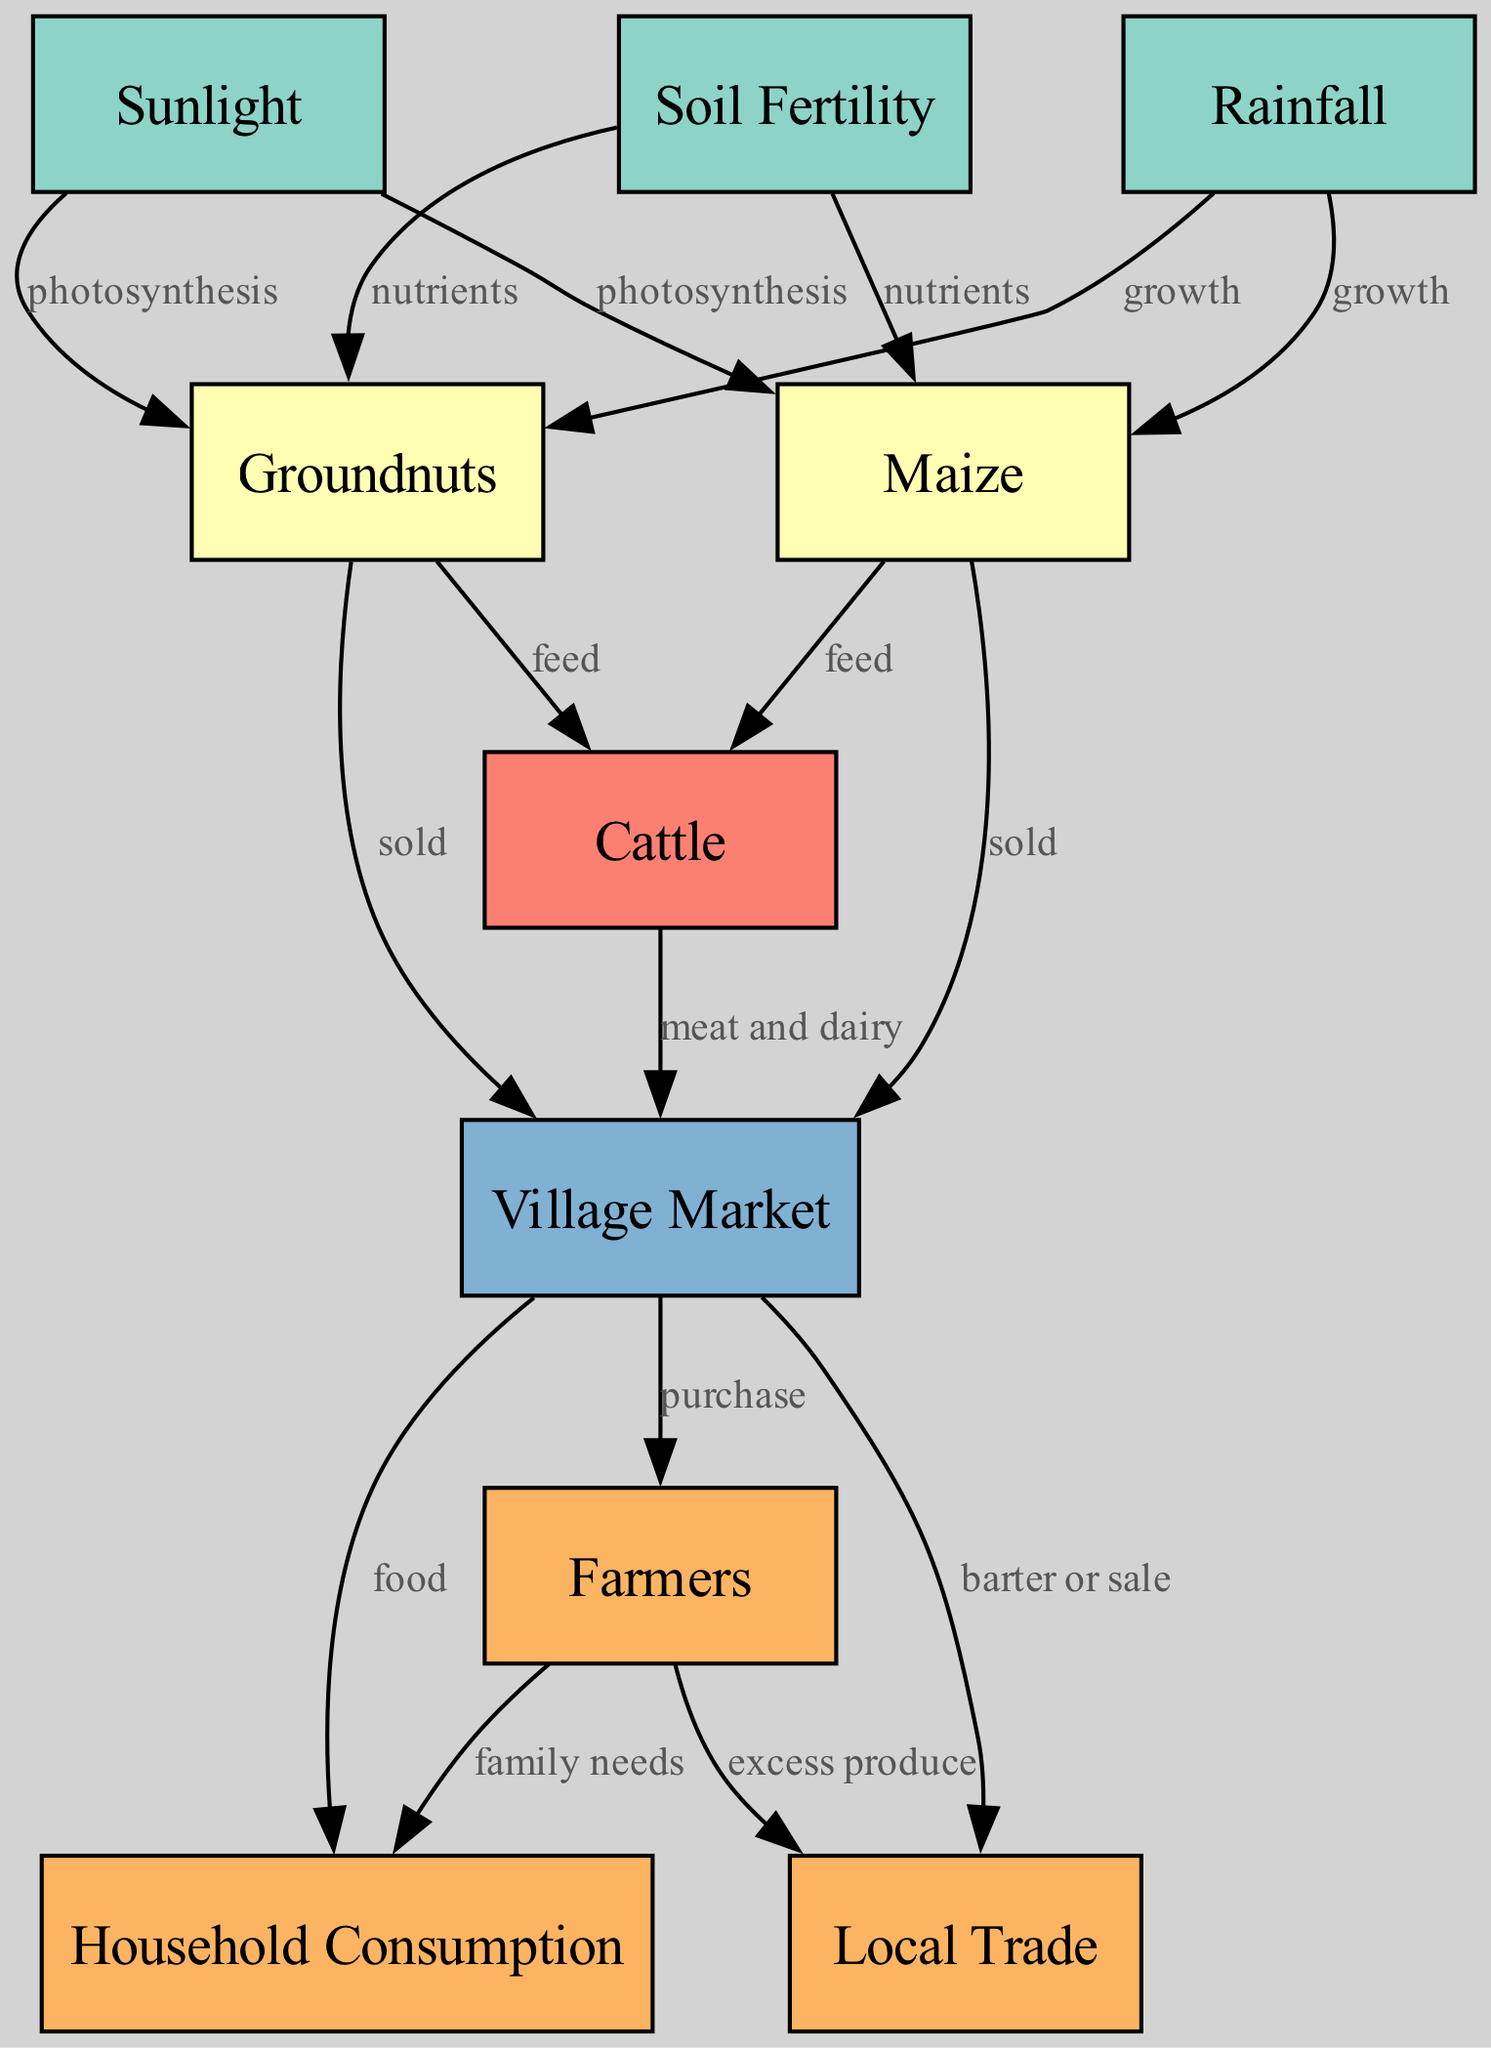What are the three elements in the environmental category? The environmental category consists of nodes that represent fundamental components affecting the food chain. These are Sunlight, Rainfall, and Soil Fertility.
Answer: Sunlight, Rainfall, Soil Fertility How many crop nodes are present in the diagram? The crop nodes are identified as Maize and Groundnuts. Counting these gives a total of two crop nodes in the diagram.
Answer: 2 What do farmers primarily purchase from the village market? The village market connects to several nodes, but the primary products associated with it include food and other goods that fulfill family needs. Hence, the primary focus would be on food.
Answer: Food What type of animal is primarily fed by maize? Maize serves as feed not only for cattle but also for other livestock in the agricultural context, indicating that the primary animal fed is cattle.
Answer: Cattle How does rainfall directly influence crops in the diagram? Rainfall has a direct link to both maize and groundnuts as it facilitates their growth. This relationship shows how rainfall is essential for crop health.
Answer: Growth Which node illustrates the final step of the local food chain? The local food chain culminates at the Household Consumption node, demonstrating where food produced is ultimately consumed.
Answer: Household Consumption What relationships connect cattle to the village market? Cattle produce meat and dairy products, which are sold at the village market. Thus, the relationships include the transformation of cattle into marketable products.
Answer: Meat and dairy What do farmers do with excess produce according to the diagram? Any surplus yield from farming is directed towards local trade, indicating that farmers engage in barter or sale to utilize their excess produce effectively.
Answer: Local trade 